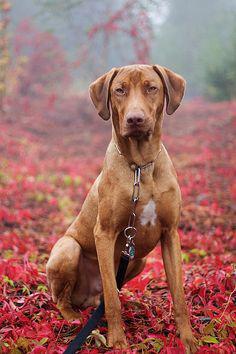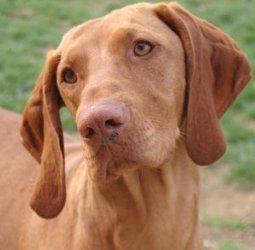The first image is the image on the left, the second image is the image on the right. Considering the images on both sides, is "One image features a dog in a collar with his head angled to the left and his tongue hanging down." valid? Answer yes or no. No. The first image is the image on the left, the second image is the image on the right. For the images displayed, is the sentence "The dogs in both of the images are outside." factually correct? Answer yes or no. Yes. 